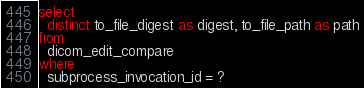<code> <loc_0><loc_0><loc_500><loc_500><_SQL_>select 
  distinct to_file_digest as digest, to_file_path as path
from
  dicom_edit_compare
where
  subprocess_invocation_id = ?</code> 